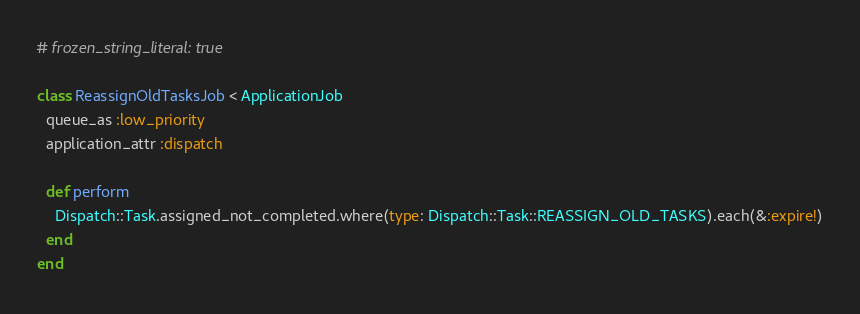Convert code to text. <code><loc_0><loc_0><loc_500><loc_500><_Ruby_># frozen_string_literal: true

class ReassignOldTasksJob < ApplicationJob
  queue_as :low_priority
  application_attr :dispatch

  def perform
    Dispatch::Task.assigned_not_completed.where(type: Dispatch::Task::REASSIGN_OLD_TASKS).each(&:expire!)
  end
end
</code> 